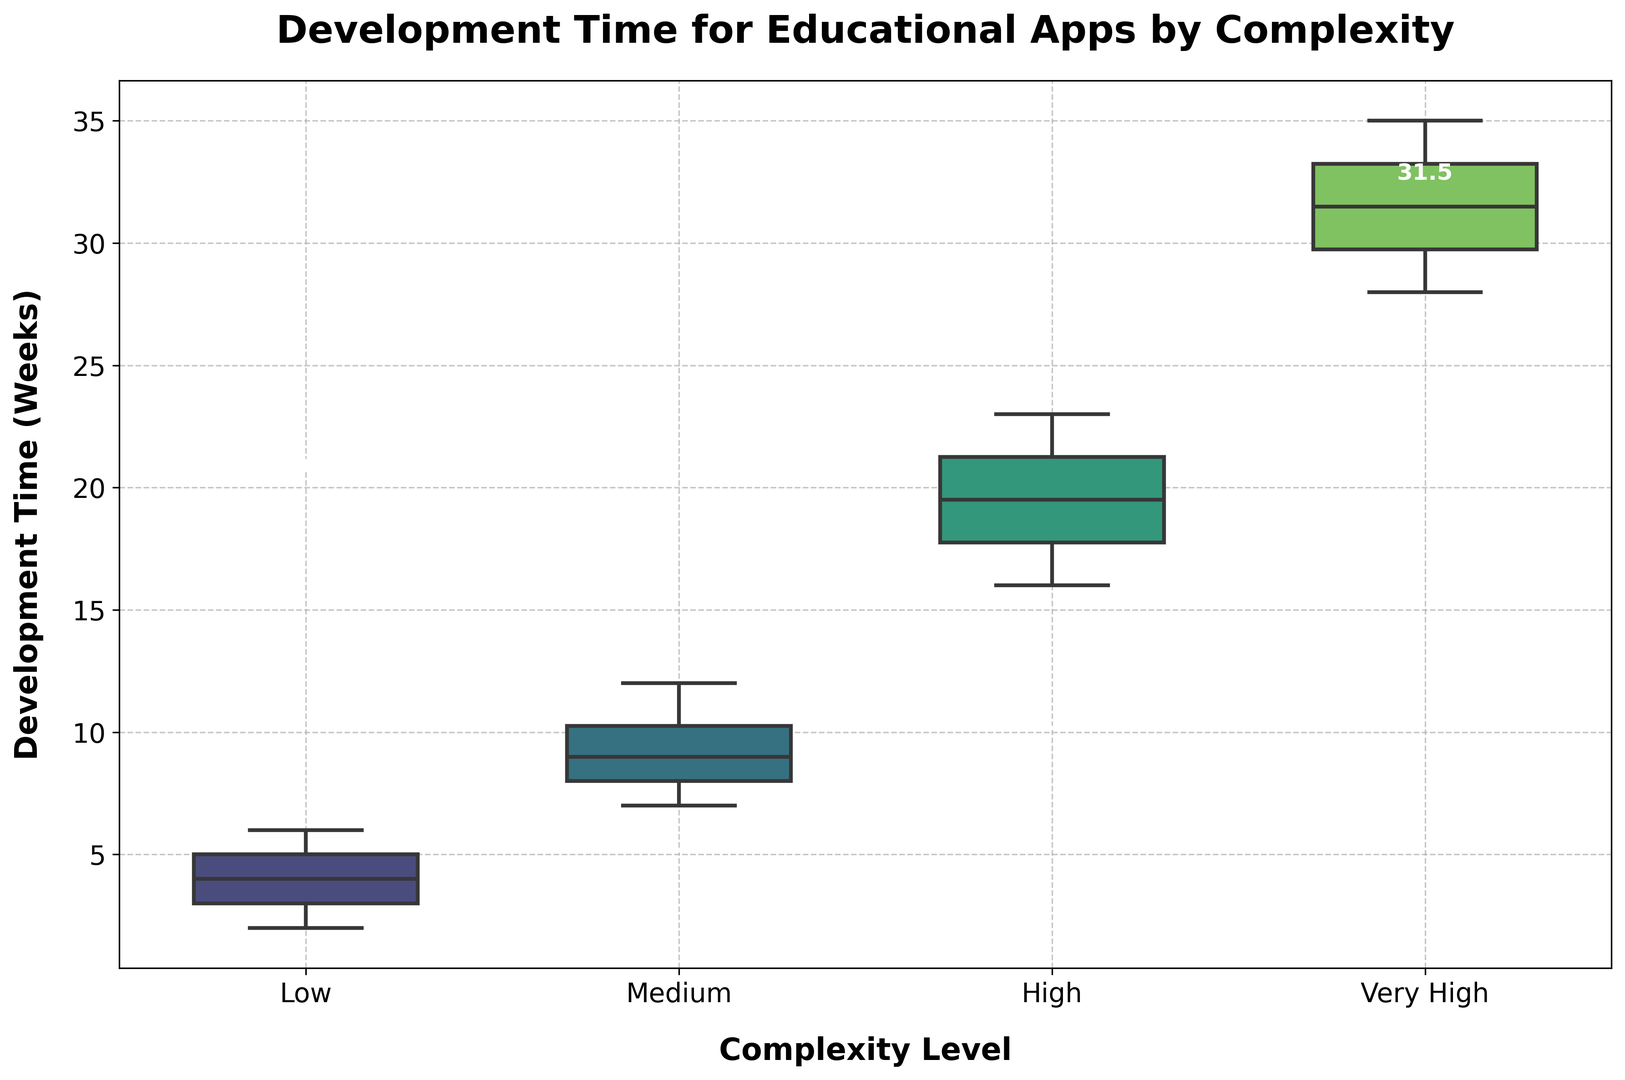What is the median development time for Medium complexity apps? Identify the position of the "Medium" complexity boxplot. The median is the line inside the box, look for the numerical annotation.
Answer: 9 weeks Which complexity level has the highest median development time? Compare the median lines within each boxplot. "Very High" complexity has the median line at the highest position.
Answer: Very High What is the interquartile range (IQR) for High complexity apps? Locate the top (Q3) and bottom (Q1) edges of the box for "High" complexity. Q3 is at 21, and Q1 is at 17. IQR = Q3 - Q1. Hence, IQR = 21 - 17.
Answer: 4 weeks Which complexity level shows the most variability in development time? Observe the height of each box and the length of the whiskers. "Very High" complexity has the largest span.
Answer: Very High Is the development time for Low complexity apps more or less variable than for Medium complexity apps? Compare the height of the boxes and whiskers. "Low" complexity has a shorter range than "Medium," indicating less variability.
Answer: Less How does the maximum development time for Medium complexity compare to that of High complexity? Identify the top whisker of the "Medium" and "High" boxes. The max for "Medium" is at 12, and for "High" is at 23. 23 is greater than 12.
Answer: Less (12 weeks vs. 23 weeks) Does any complexity level have outliers in the data? Check if there are any data points outside the whiskers for any boxplot. Based on the provided data and visual, no outliers are indicated.
Answer: No What is the difference in median development time between Low and High complexity apps? Identify the medians for "Low" (4) and "High" (19). Calculate the difference: 19 - 4.
Answer: 15 weeks Which complexity level has the smallest range of developmental time? Compare the total span (from minimum to the maximum including whiskers) of each boxplot. "Low" complexity has the smallest range.
Answer: Low How does the lower quartile for Very High complexity compare to the upper quartile for Medium complexity? Locate Q1 for "Very High" (29) and Q3 for "Medium" (10). Compare 29 with 10.
Answer: Higher (29 weeks vs. 10 weeks) 